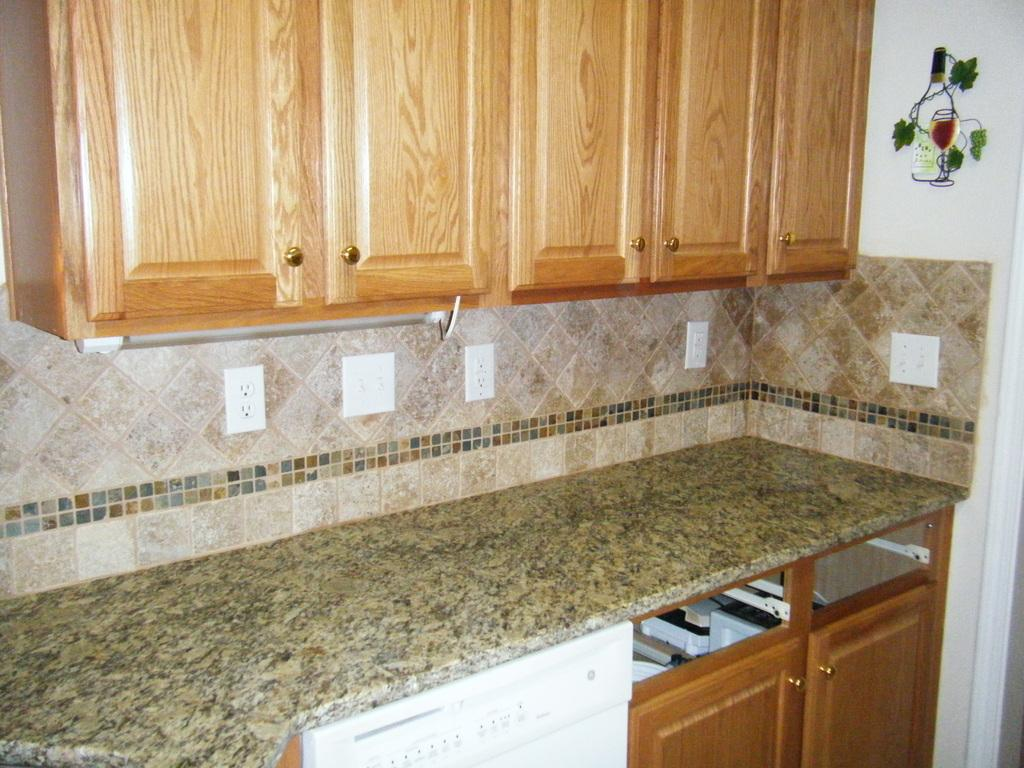What type of furniture is present in the image? There are cupboards in the image. What surface can be seen in the image? There is a countertop in the image. What is located under the countertop? There is a white-colored thing under the countertop. What electrical feature is visible in the image? There are power sockets in the image. What type of decoration is present on the walls in the image? There are stickers on the walls in the image. What type of property is being measured in the image? There is no property being measured in the image. Where is the lunchroom located in the image? There is no lunchroom present in the image. 